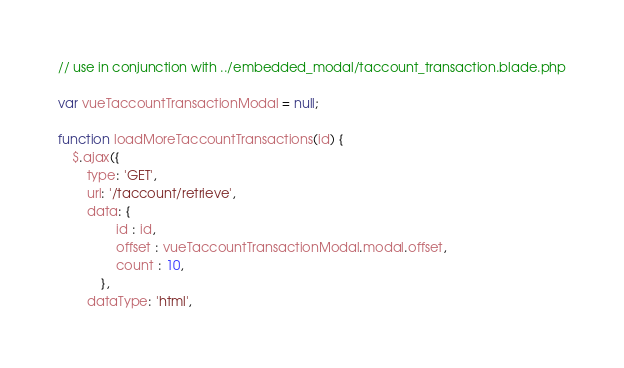<code> <loc_0><loc_0><loc_500><loc_500><_JavaScript_>// use in conjunction with ../embedded_modal/taccount_transaction.blade.php

var vueTaccountTransactionModal = null;

function loadMoreTaccountTransactions(id) {
	$.ajax({
		type: 'GET',
		url: '/taccount/retrieve',
		data: {
				id : id,
				offset : vueTaccountTransactionModal.modal.offset,
				count : 10,
			},
		dataType: 'html',</code> 